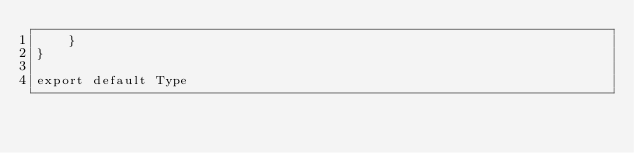Convert code to text. <code><loc_0><loc_0><loc_500><loc_500><_JavaScript_>    }
}

export default Type</code> 